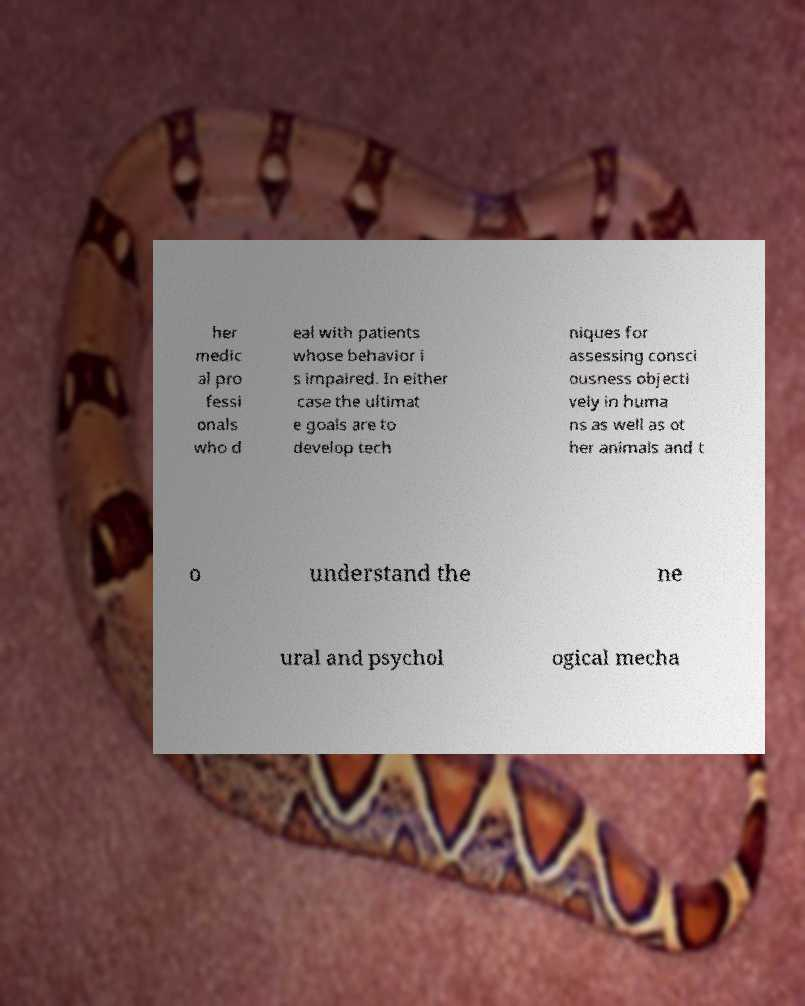Could you assist in decoding the text presented in this image and type it out clearly? her medic al pro fessi onals who d eal with patients whose behavior i s impaired. In either case the ultimat e goals are to develop tech niques for assessing consci ousness objecti vely in huma ns as well as ot her animals and t o understand the ne ural and psychol ogical mecha 